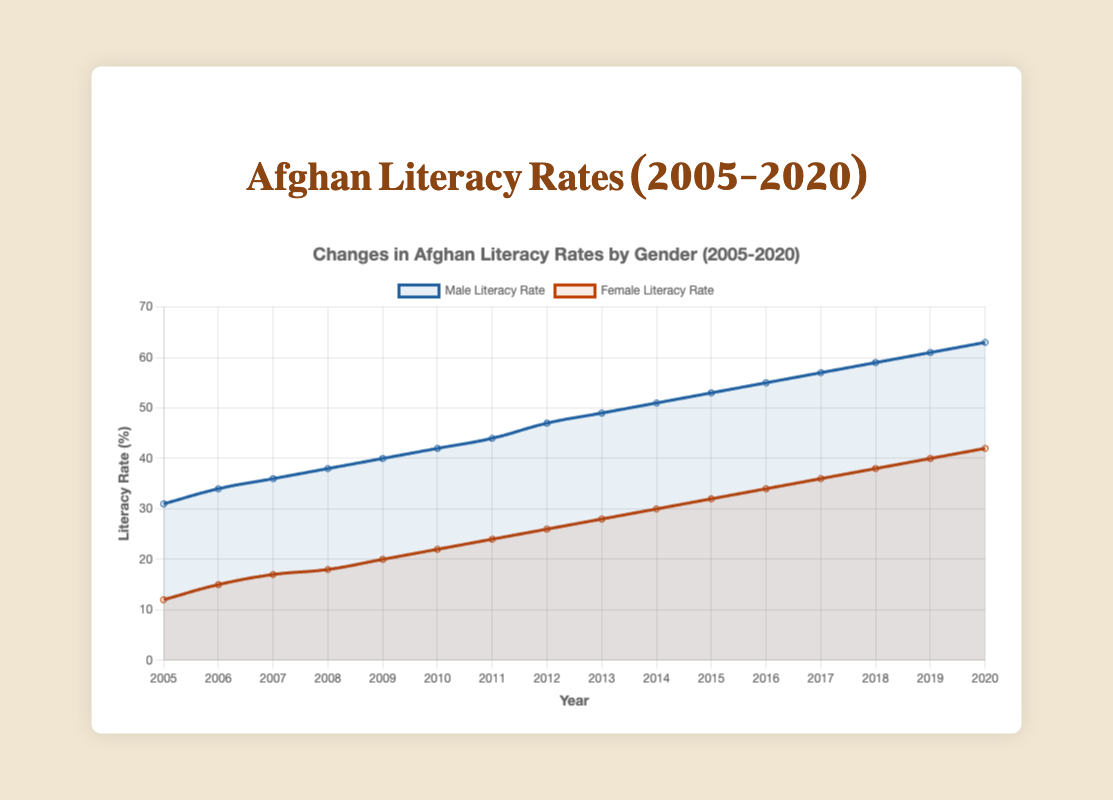What is the male literacy rate in 2010? Look for the data point corresponding to the male literacy rate for the year 2010.
Answer: 42 In which year did the female literacy rate surpass 20%? Identify the first year where the female literacy rate is greater than 20%.
Answer: 2009 Which gender had a higher literacy rate in 2015, and by how much? Compare the male and female literacy rates for the year 2015 and calculate the difference.
Answer: Male by 21% By how many percentage points did the female literacy rate increase from 2005 to 2020? Subtract the female literacy rate in 2005 from the female literacy rate in 2020.
Answer: 30 Compare the change in male literacy rates to female literacy rates over the entire period. Which increased more? Determine the difference between the literacy rates in 2005 and 2020 for both males and females, and compare the differences.
Answer: Female increased more What was the average male literacy rate between 2009 and 2014? Sum the male literacy rates from 2009 to 2014 and divide by the number of years (2014 - 2009 + 1).
Answer: 47 What is the visual trend of the female literacy rate from 2012 to 2020? Examine the line graph's trend for the female literacy rate from 2012 to 2020.
Answer: Increasing Which year saw the largest increase in male literacy rate, and what was the increase? Calculate the year-to-year differences for male literacy rates and find the maximum difference.
Answer: 2012 with an increase of 3% Is there any year where the literacy rates for both genders are equal? Compare the data points for male and female literacy rates to check for equality.
Answer: No 